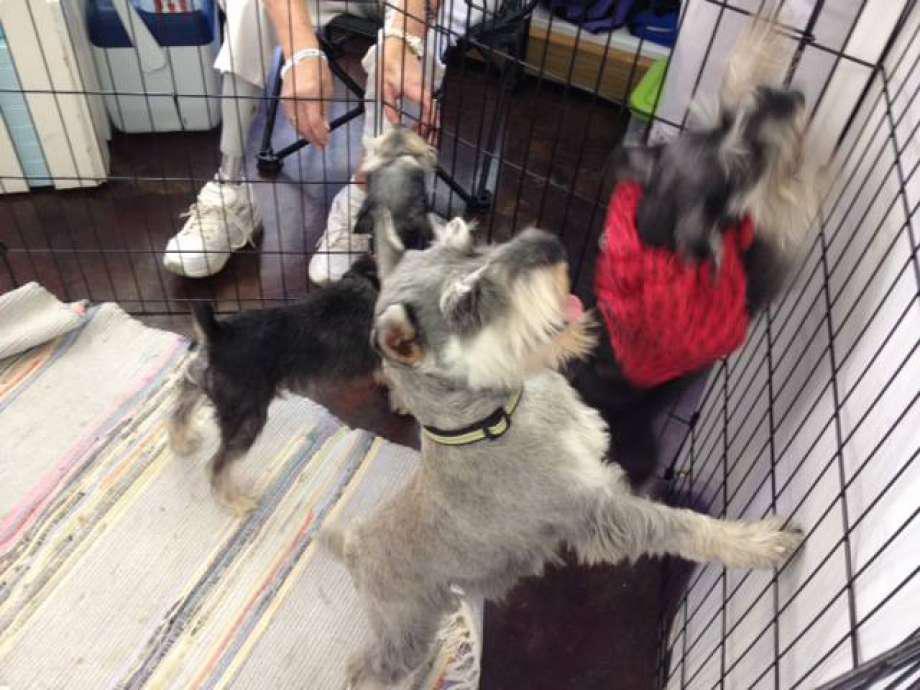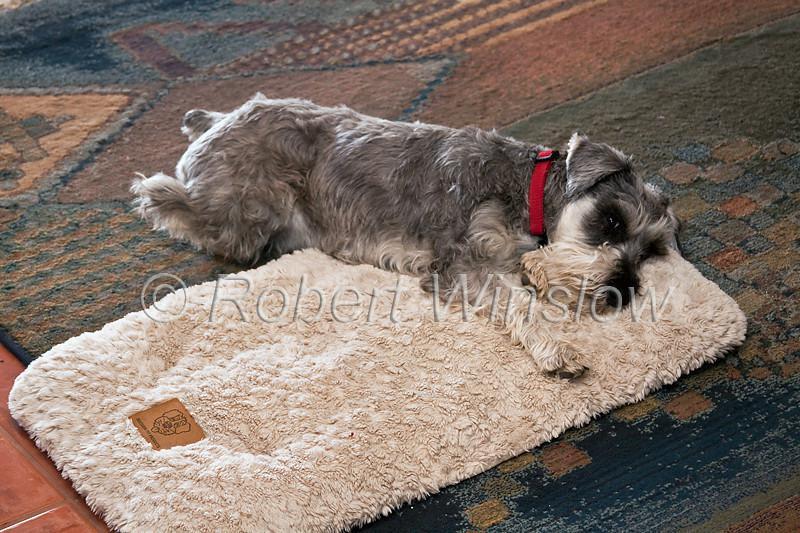The first image is the image on the left, the second image is the image on the right. For the images displayed, is the sentence "There are four dogs total." factually correct? Answer yes or no. Yes. 